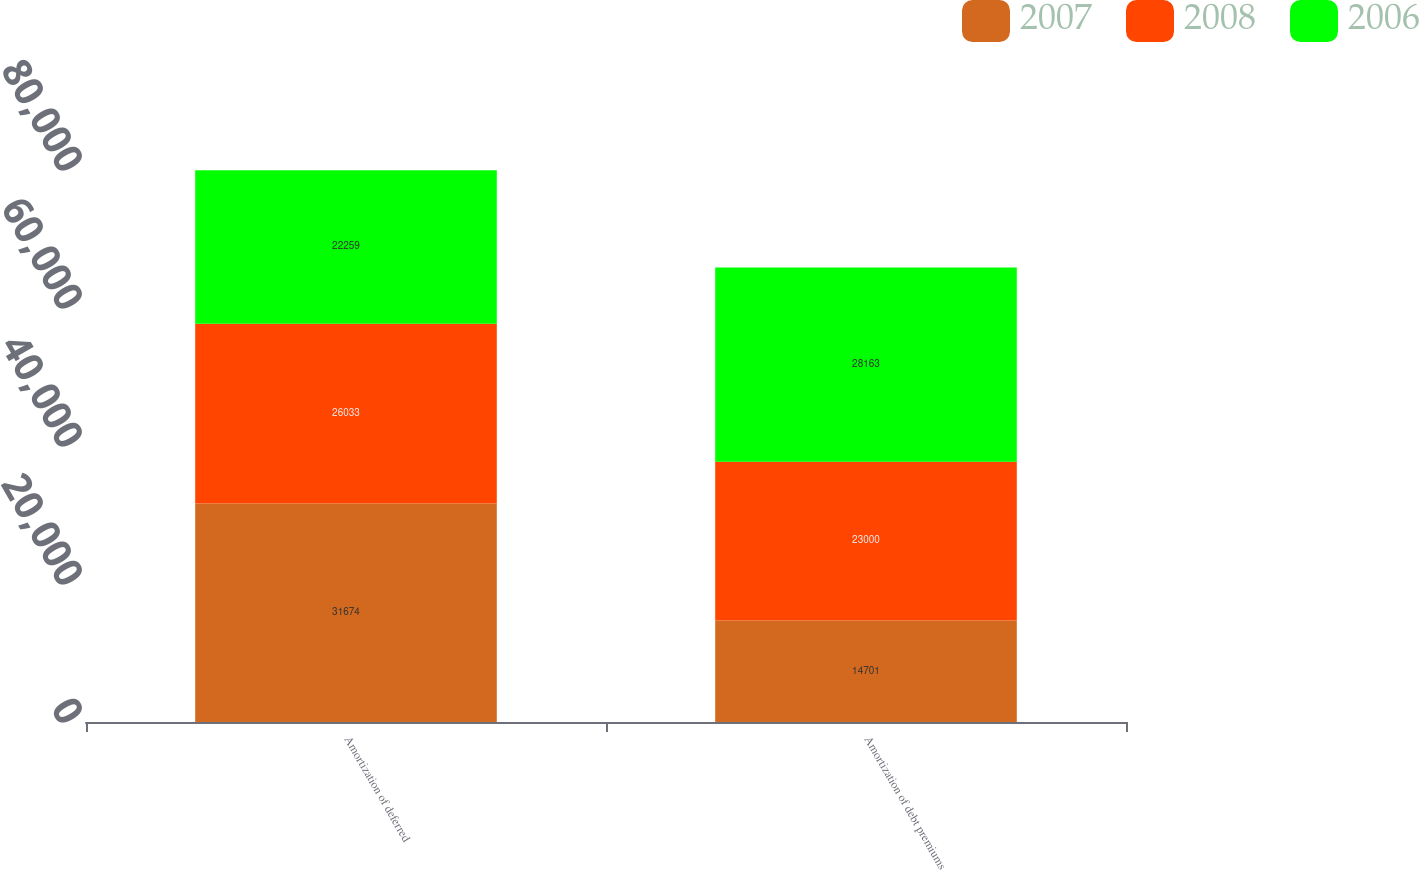<chart> <loc_0><loc_0><loc_500><loc_500><stacked_bar_chart><ecel><fcel>Amortization of deferred<fcel>Amortization of debt premiums<nl><fcel>2007<fcel>31674<fcel>14701<nl><fcel>2008<fcel>26033<fcel>23000<nl><fcel>2006<fcel>22259<fcel>28163<nl></chart> 